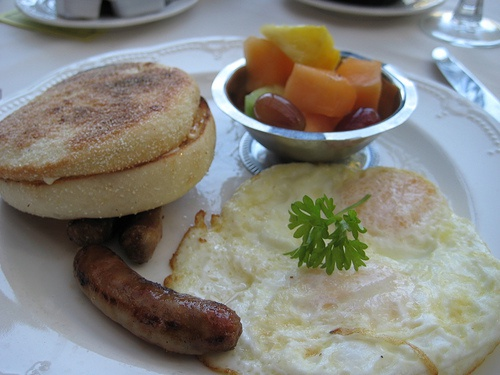Describe the objects in this image and their specific colors. I can see sandwich in gray and darkgray tones, bowl in gray, maroon, olive, lightblue, and black tones, hot dog in gray, black, and maroon tones, orange in gray, olive, and darkgray tones, and knife in gray, lightblue, and darkgray tones in this image. 